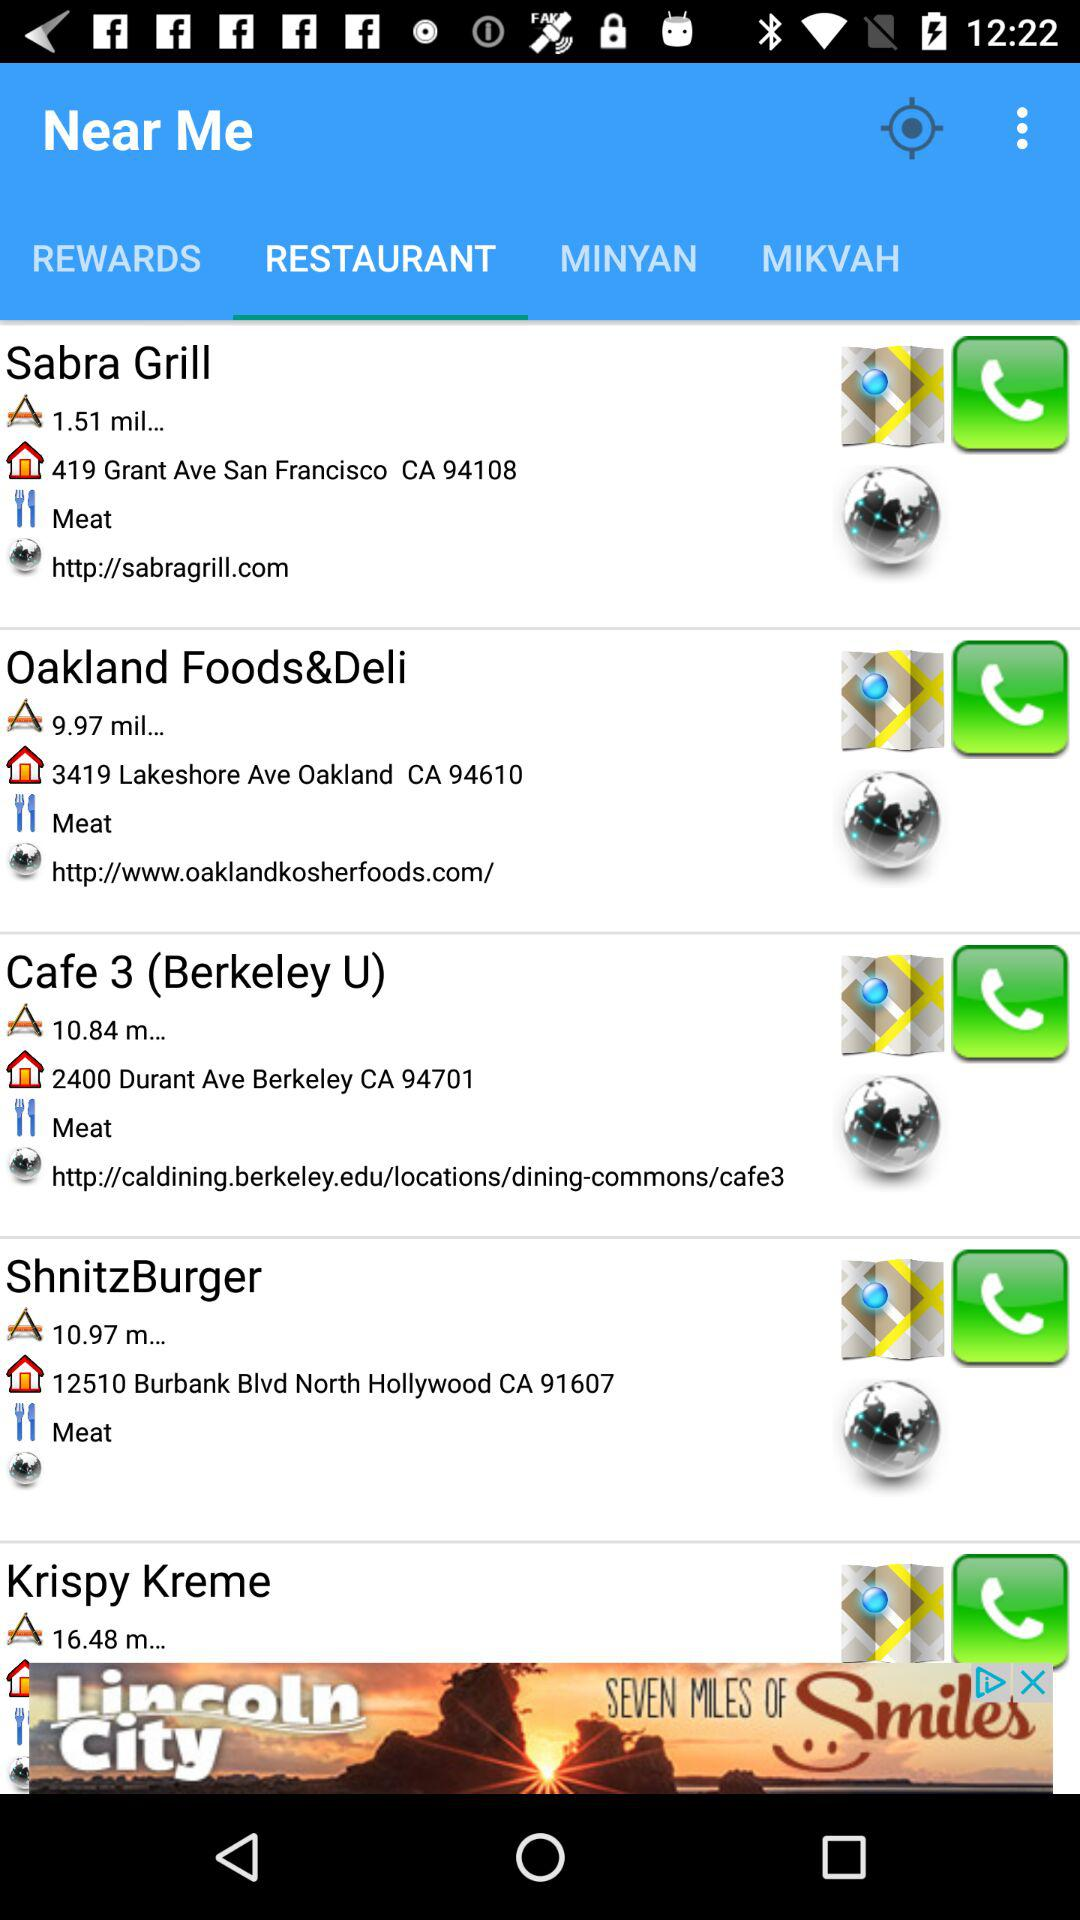What is the location of Cafe 3? The location is "2400 Durant Ave Berkeley CA 94701". 